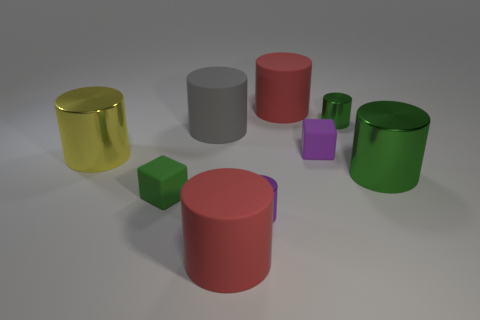Can you tell me the order of the objects from left to right based on their heights? Starting from the left, the order based on height seems to be: gold cylinder, grey cylinder, green cylinder, purple cube, pink cylinder, green cube, and the red cylinder on the far right. 